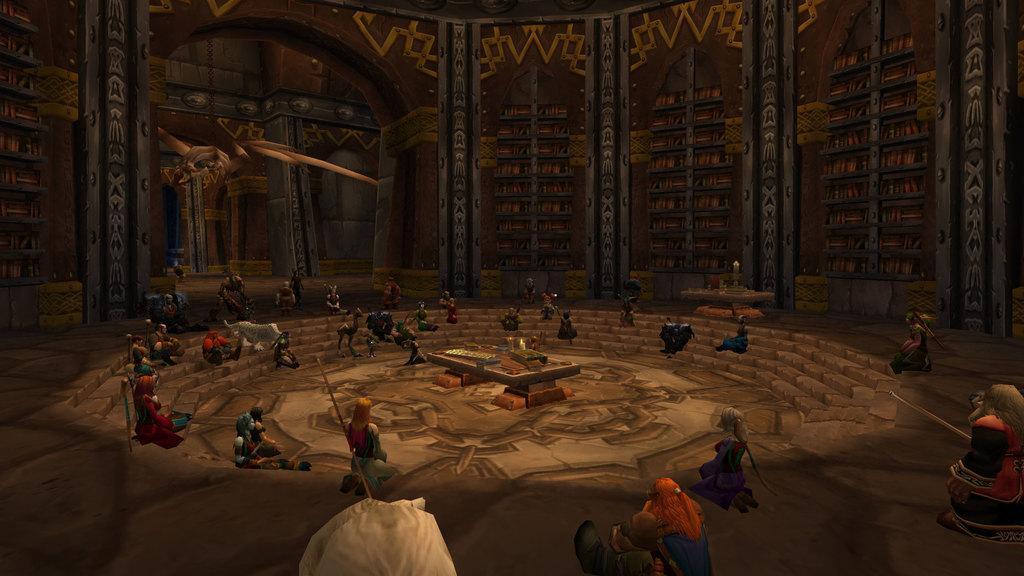Could you give a brief overview of what you see in this image? This picture is animated. This picture is inside view of a room. we can see some persons, wall and some objects are there. 